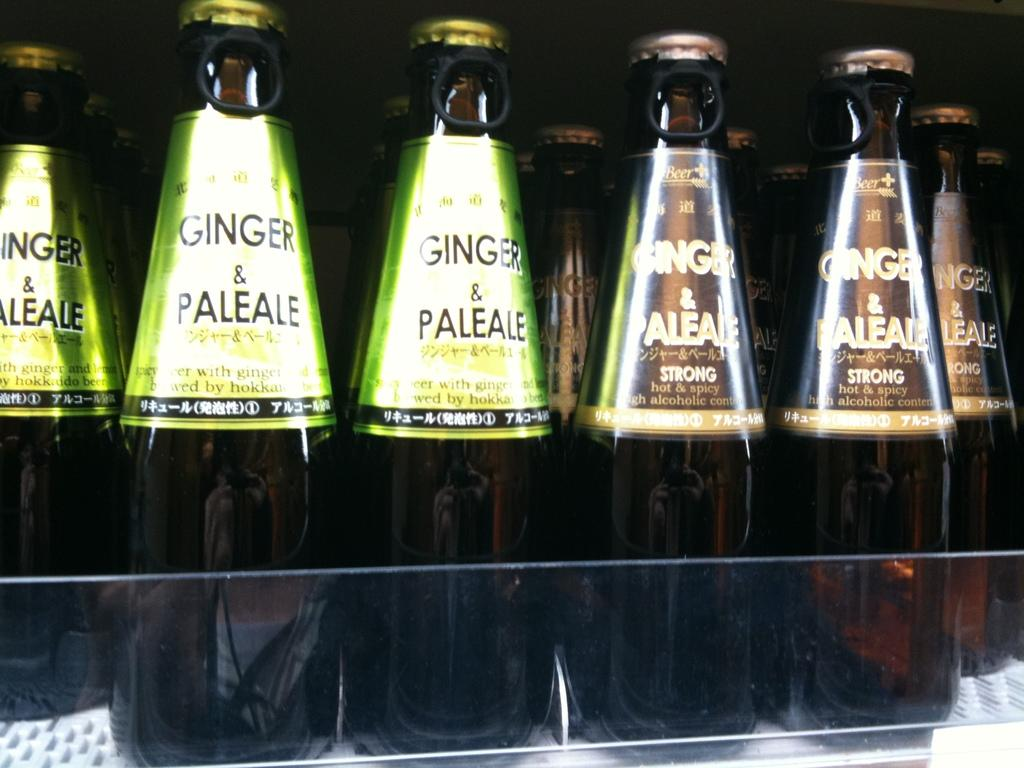<image>
Present a compact description of the photo's key features. several bottles of Ginger and Pale Ale in a display case 